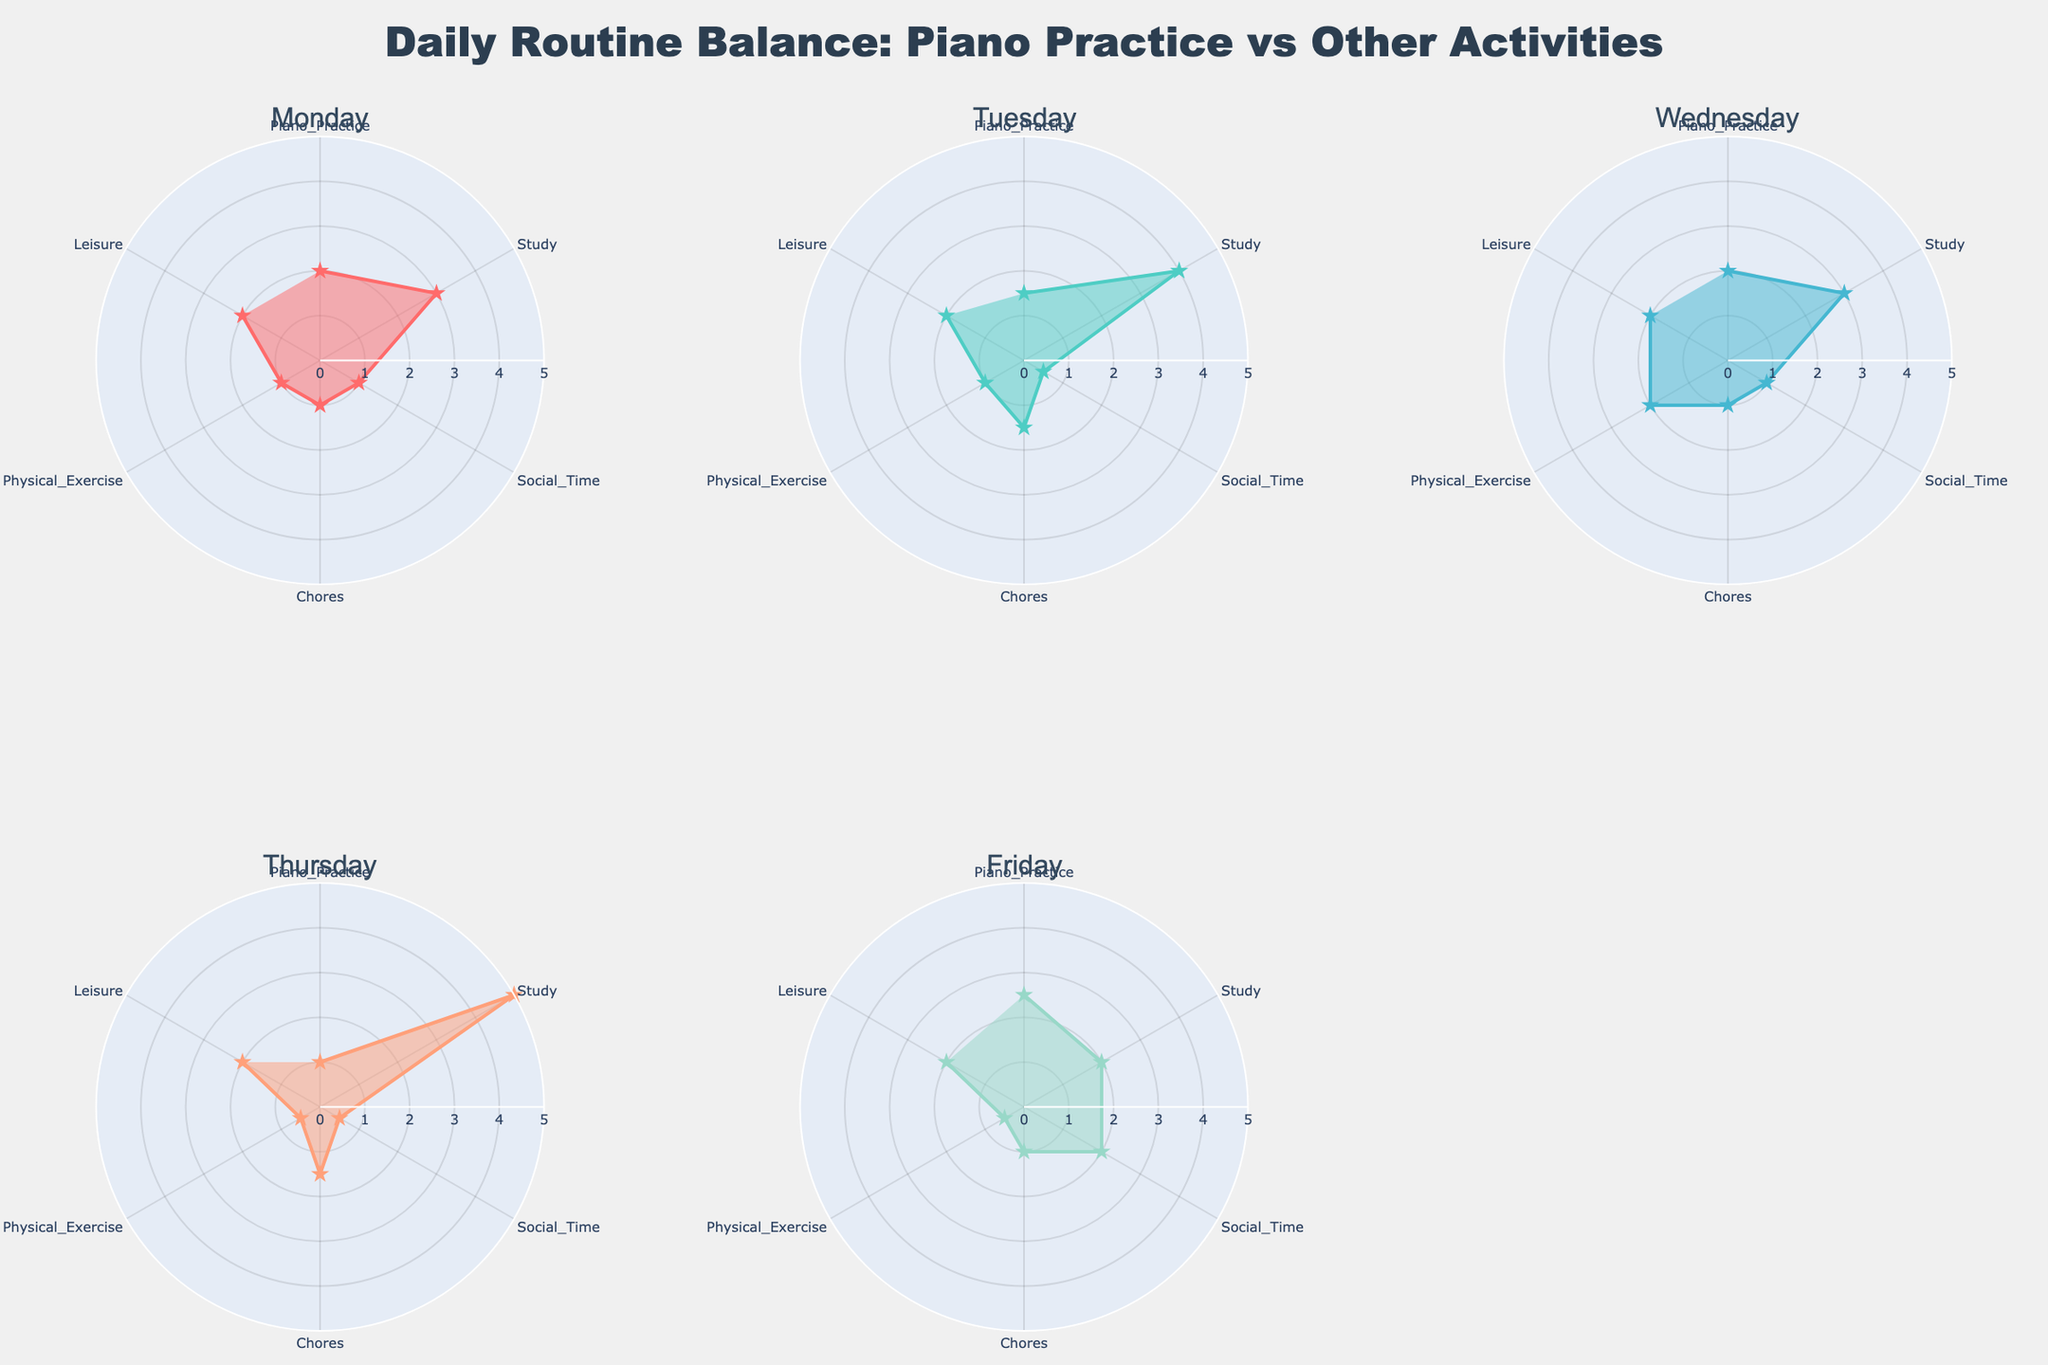What is the title of the figure? The title is located at the top of the figure, giving an overall description of what the chart represents. According to the provided code, the title is "Daily Routine Balance: Piano Practice vs Other Activities".
Answer: Daily Routine Balance: Piano Practice vs Other Activities How many days are shown in the radar chart subplot? Each subplot in the figure represents data for one day, and there are six subplots indicating six different days. The unique days visible are Monday, Tuesday, Wednesday, Thursday, and Friday.
Answer: 5 days Which day has the highest total time spent on study? By examining the plots, look for the day with the largest value in the study section of their radar charts. Thursday shows the highest single value for study at 5 hours.
Answer: Thursday Which day has the least amount of social time? Compare the values under "Social Time" for each day. The day with the smallest value is Thursday with 0.5 hours.
Answer: Thursday On which days are the piano practice hours identical? By comparing the radar plots for each day under "Piano Practice," you will find that both Monday and Wednesday show identical values of 2 hours each.
Answer: Monday and Wednesday If you sum up the leisure hours from Monday and Friday, what is the total? According to the radar charts, Leisure hours are 2 on Monday and 2 on Friday. The sum is 2 + 2 = 4 hours.
Answer: 4 hours On which day is there the most balanced time distribution across all activities? A balanced distribution can be identified by observing which radar chart appears most symmetrical. Friday's chart is more balanced compared to others, with activities ranging between 0.5 to 2.5 hours, ensuring fairly even distribution.
Answer: Friday Which day has the maximum hours spent on physical exercise? Examining the radar plots, look at the values under "Physical Exercise." Wednesday has the maximum value of 2 hours.
Answer: Wednesday How does the time spent on chores compare between Monday and Thursday? Compare the radar plots for Monday and Thursday under "Chores." Both days show identical values of 1.5 hours each.
Answer: Equal, 1.5 hours Which day spends the least time on leisure, and how many hours? By reviewing the leisure section on each radar chart, all days indicate 2 hours spent on leisure, making it constant across all days.
Answer: Every day, 2 hours 